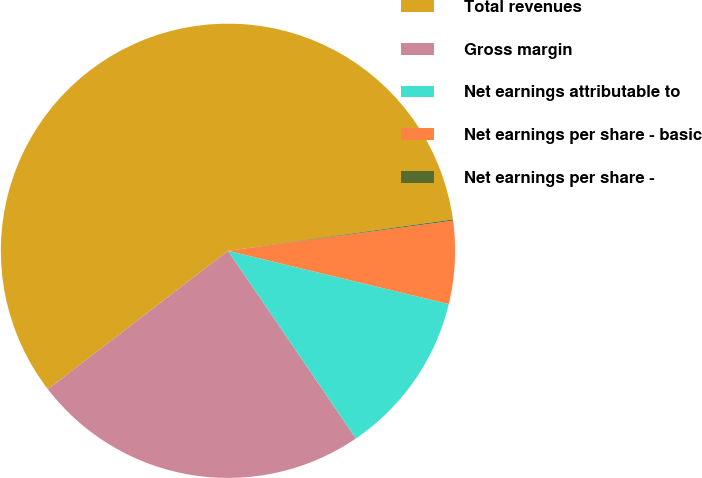<chart> <loc_0><loc_0><loc_500><loc_500><pie_chart><fcel>Total revenues<fcel>Gross margin<fcel>Net earnings attributable to<fcel>Net earnings per share - basic<fcel>Net earnings per share -<nl><fcel>58.23%<fcel>24.1%<fcel>11.71%<fcel>5.89%<fcel>0.08%<nl></chart> 